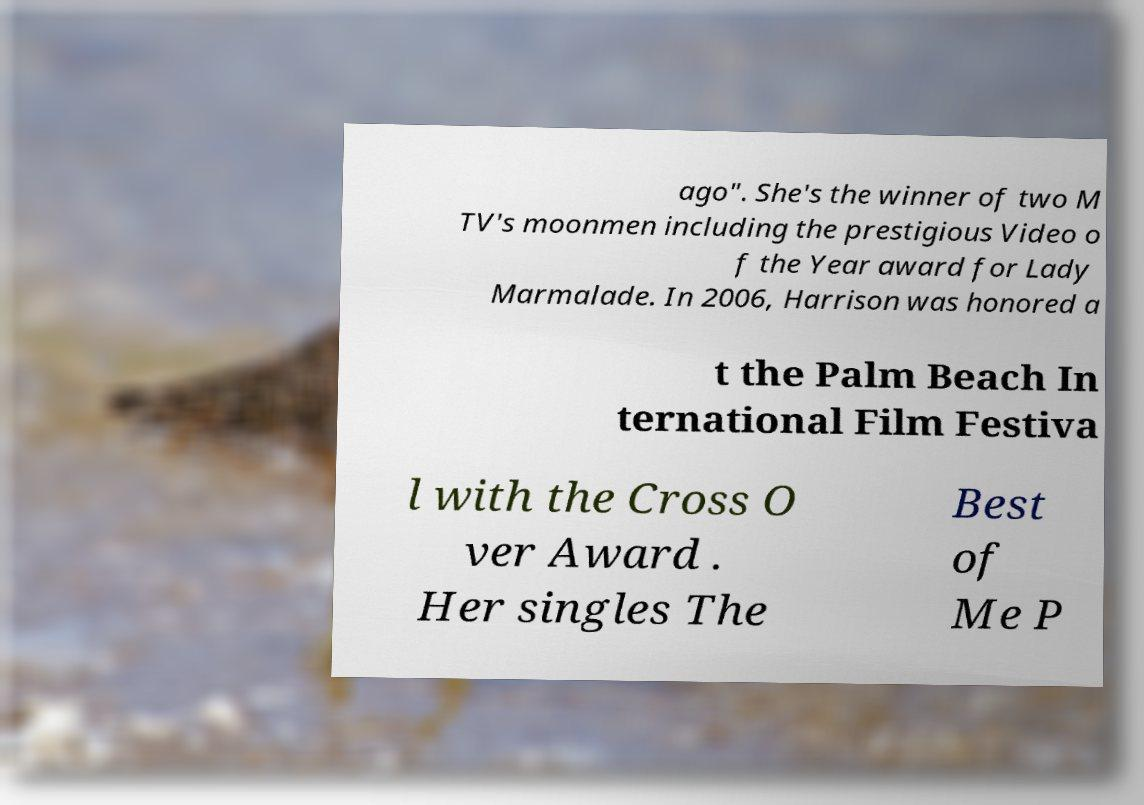Please identify and transcribe the text found in this image. ago". She's the winner of two M TV's moonmen including the prestigious Video o f the Year award for Lady Marmalade. In 2006, Harrison was honored a t the Palm Beach In ternational Film Festiva l with the Cross O ver Award . Her singles The Best of Me P 